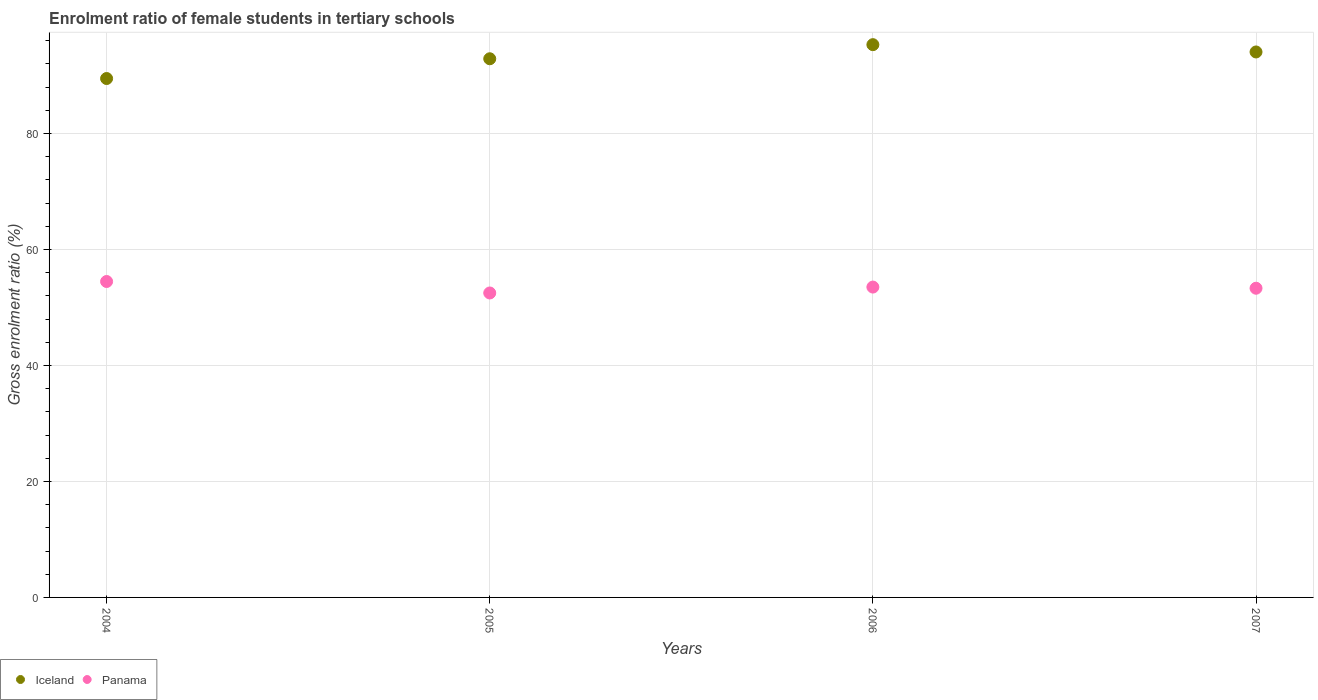How many different coloured dotlines are there?
Provide a succinct answer. 2. What is the enrolment ratio of female students in tertiary schools in Panama in 2006?
Give a very brief answer. 53.51. Across all years, what is the maximum enrolment ratio of female students in tertiary schools in Iceland?
Your answer should be compact. 95.3. Across all years, what is the minimum enrolment ratio of female students in tertiary schools in Panama?
Your answer should be very brief. 52.49. What is the total enrolment ratio of female students in tertiary schools in Panama in the graph?
Make the answer very short. 213.77. What is the difference between the enrolment ratio of female students in tertiary schools in Iceland in 2004 and that in 2006?
Offer a very short reply. -5.84. What is the difference between the enrolment ratio of female students in tertiary schools in Panama in 2006 and the enrolment ratio of female students in tertiary schools in Iceland in 2007?
Your answer should be compact. -40.53. What is the average enrolment ratio of female students in tertiary schools in Iceland per year?
Make the answer very short. 92.92. In the year 2007, what is the difference between the enrolment ratio of female students in tertiary schools in Iceland and enrolment ratio of female students in tertiary schools in Panama?
Ensure brevity in your answer.  40.74. In how many years, is the enrolment ratio of female students in tertiary schools in Iceland greater than 8 %?
Make the answer very short. 4. What is the ratio of the enrolment ratio of female students in tertiary schools in Panama in 2004 to that in 2007?
Make the answer very short. 1.02. Is the enrolment ratio of female students in tertiary schools in Iceland in 2004 less than that in 2007?
Provide a short and direct response. Yes. Is the difference between the enrolment ratio of female students in tertiary schools in Iceland in 2006 and 2007 greater than the difference between the enrolment ratio of female students in tertiary schools in Panama in 2006 and 2007?
Your answer should be very brief. Yes. What is the difference between the highest and the second highest enrolment ratio of female students in tertiary schools in Panama?
Make the answer very short. 0.96. What is the difference between the highest and the lowest enrolment ratio of female students in tertiary schools in Iceland?
Your response must be concise. 5.84. Is the enrolment ratio of female students in tertiary schools in Panama strictly greater than the enrolment ratio of female students in tertiary schools in Iceland over the years?
Your answer should be very brief. No. Is the enrolment ratio of female students in tertiary schools in Panama strictly less than the enrolment ratio of female students in tertiary schools in Iceland over the years?
Offer a terse response. Yes. How many dotlines are there?
Ensure brevity in your answer.  2. How many years are there in the graph?
Give a very brief answer. 4. Are the values on the major ticks of Y-axis written in scientific E-notation?
Your response must be concise. No. Does the graph contain grids?
Your answer should be very brief. Yes. How are the legend labels stacked?
Your answer should be very brief. Horizontal. What is the title of the graph?
Keep it short and to the point. Enrolment ratio of female students in tertiary schools. Does "Gabon" appear as one of the legend labels in the graph?
Provide a short and direct response. No. What is the label or title of the X-axis?
Provide a short and direct response. Years. What is the label or title of the Y-axis?
Keep it short and to the point. Gross enrolment ratio (%). What is the Gross enrolment ratio (%) in Iceland in 2004?
Your response must be concise. 89.46. What is the Gross enrolment ratio (%) of Panama in 2004?
Provide a succinct answer. 54.47. What is the Gross enrolment ratio (%) in Iceland in 2005?
Offer a very short reply. 92.87. What is the Gross enrolment ratio (%) in Panama in 2005?
Your answer should be compact. 52.49. What is the Gross enrolment ratio (%) in Iceland in 2006?
Offer a very short reply. 95.3. What is the Gross enrolment ratio (%) of Panama in 2006?
Your answer should be very brief. 53.51. What is the Gross enrolment ratio (%) of Iceland in 2007?
Keep it short and to the point. 94.04. What is the Gross enrolment ratio (%) of Panama in 2007?
Your response must be concise. 53.31. Across all years, what is the maximum Gross enrolment ratio (%) in Iceland?
Your answer should be very brief. 95.3. Across all years, what is the maximum Gross enrolment ratio (%) of Panama?
Your response must be concise. 54.47. Across all years, what is the minimum Gross enrolment ratio (%) in Iceland?
Your answer should be very brief. 89.46. Across all years, what is the minimum Gross enrolment ratio (%) in Panama?
Keep it short and to the point. 52.49. What is the total Gross enrolment ratio (%) of Iceland in the graph?
Your answer should be compact. 371.67. What is the total Gross enrolment ratio (%) of Panama in the graph?
Your response must be concise. 213.77. What is the difference between the Gross enrolment ratio (%) of Iceland in 2004 and that in 2005?
Your response must be concise. -3.41. What is the difference between the Gross enrolment ratio (%) of Panama in 2004 and that in 2005?
Provide a short and direct response. 1.98. What is the difference between the Gross enrolment ratio (%) of Iceland in 2004 and that in 2006?
Make the answer very short. -5.84. What is the difference between the Gross enrolment ratio (%) in Panama in 2004 and that in 2006?
Provide a succinct answer. 0.96. What is the difference between the Gross enrolment ratio (%) in Iceland in 2004 and that in 2007?
Keep it short and to the point. -4.58. What is the difference between the Gross enrolment ratio (%) in Panama in 2004 and that in 2007?
Provide a short and direct response. 1.16. What is the difference between the Gross enrolment ratio (%) in Iceland in 2005 and that in 2006?
Make the answer very short. -2.43. What is the difference between the Gross enrolment ratio (%) in Panama in 2005 and that in 2006?
Ensure brevity in your answer.  -1.02. What is the difference between the Gross enrolment ratio (%) of Iceland in 2005 and that in 2007?
Offer a very short reply. -1.17. What is the difference between the Gross enrolment ratio (%) of Panama in 2005 and that in 2007?
Make the answer very short. -0.82. What is the difference between the Gross enrolment ratio (%) in Iceland in 2006 and that in 2007?
Your response must be concise. 1.26. What is the difference between the Gross enrolment ratio (%) in Panama in 2006 and that in 2007?
Ensure brevity in your answer.  0.2. What is the difference between the Gross enrolment ratio (%) in Iceland in 2004 and the Gross enrolment ratio (%) in Panama in 2005?
Provide a succinct answer. 36.97. What is the difference between the Gross enrolment ratio (%) in Iceland in 2004 and the Gross enrolment ratio (%) in Panama in 2006?
Make the answer very short. 35.95. What is the difference between the Gross enrolment ratio (%) of Iceland in 2004 and the Gross enrolment ratio (%) of Panama in 2007?
Your answer should be very brief. 36.16. What is the difference between the Gross enrolment ratio (%) of Iceland in 2005 and the Gross enrolment ratio (%) of Panama in 2006?
Your answer should be compact. 39.36. What is the difference between the Gross enrolment ratio (%) in Iceland in 2005 and the Gross enrolment ratio (%) in Panama in 2007?
Offer a very short reply. 39.56. What is the difference between the Gross enrolment ratio (%) in Iceland in 2006 and the Gross enrolment ratio (%) in Panama in 2007?
Give a very brief answer. 41.99. What is the average Gross enrolment ratio (%) in Iceland per year?
Your response must be concise. 92.92. What is the average Gross enrolment ratio (%) in Panama per year?
Your response must be concise. 53.44. In the year 2004, what is the difference between the Gross enrolment ratio (%) of Iceland and Gross enrolment ratio (%) of Panama?
Offer a terse response. 34.99. In the year 2005, what is the difference between the Gross enrolment ratio (%) in Iceland and Gross enrolment ratio (%) in Panama?
Offer a very short reply. 40.38. In the year 2006, what is the difference between the Gross enrolment ratio (%) in Iceland and Gross enrolment ratio (%) in Panama?
Give a very brief answer. 41.79. In the year 2007, what is the difference between the Gross enrolment ratio (%) of Iceland and Gross enrolment ratio (%) of Panama?
Make the answer very short. 40.74. What is the ratio of the Gross enrolment ratio (%) of Iceland in 2004 to that in 2005?
Offer a terse response. 0.96. What is the ratio of the Gross enrolment ratio (%) in Panama in 2004 to that in 2005?
Offer a terse response. 1.04. What is the ratio of the Gross enrolment ratio (%) of Iceland in 2004 to that in 2006?
Provide a succinct answer. 0.94. What is the ratio of the Gross enrolment ratio (%) of Panama in 2004 to that in 2006?
Make the answer very short. 1.02. What is the ratio of the Gross enrolment ratio (%) of Iceland in 2004 to that in 2007?
Your answer should be very brief. 0.95. What is the ratio of the Gross enrolment ratio (%) in Panama in 2004 to that in 2007?
Ensure brevity in your answer.  1.02. What is the ratio of the Gross enrolment ratio (%) of Iceland in 2005 to that in 2006?
Offer a terse response. 0.97. What is the ratio of the Gross enrolment ratio (%) in Iceland in 2005 to that in 2007?
Give a very brief answer. 0.99. What is the ratio of the Gross enrolment ratio (%) of Panama in 2005 to that in 2007?
Keep it short and to the point. 0.98. What is the ratio of the Gross enrolment ratio (%) in Iceland in 2006 to that in 2007?
Offer a terse response. 1.01. What is the difference between the highest and the second highest Gross enrolment ratio (%) in Iceland?
Provide a succinct answer. 1.26. What is the difference between the highest and the second highest Gross enrolment ratio (%) of Panama?
Your answer should be compact. 0.96. What is the difference between the highest and the lowest Gross enrolment ratio (%) in Iceland?
Keep it short and to the point. 5.84. What is the difference between the highest and the lowest Gross enrolment ratio (%) of Panama?
Give a very brief answer. 1.98. 